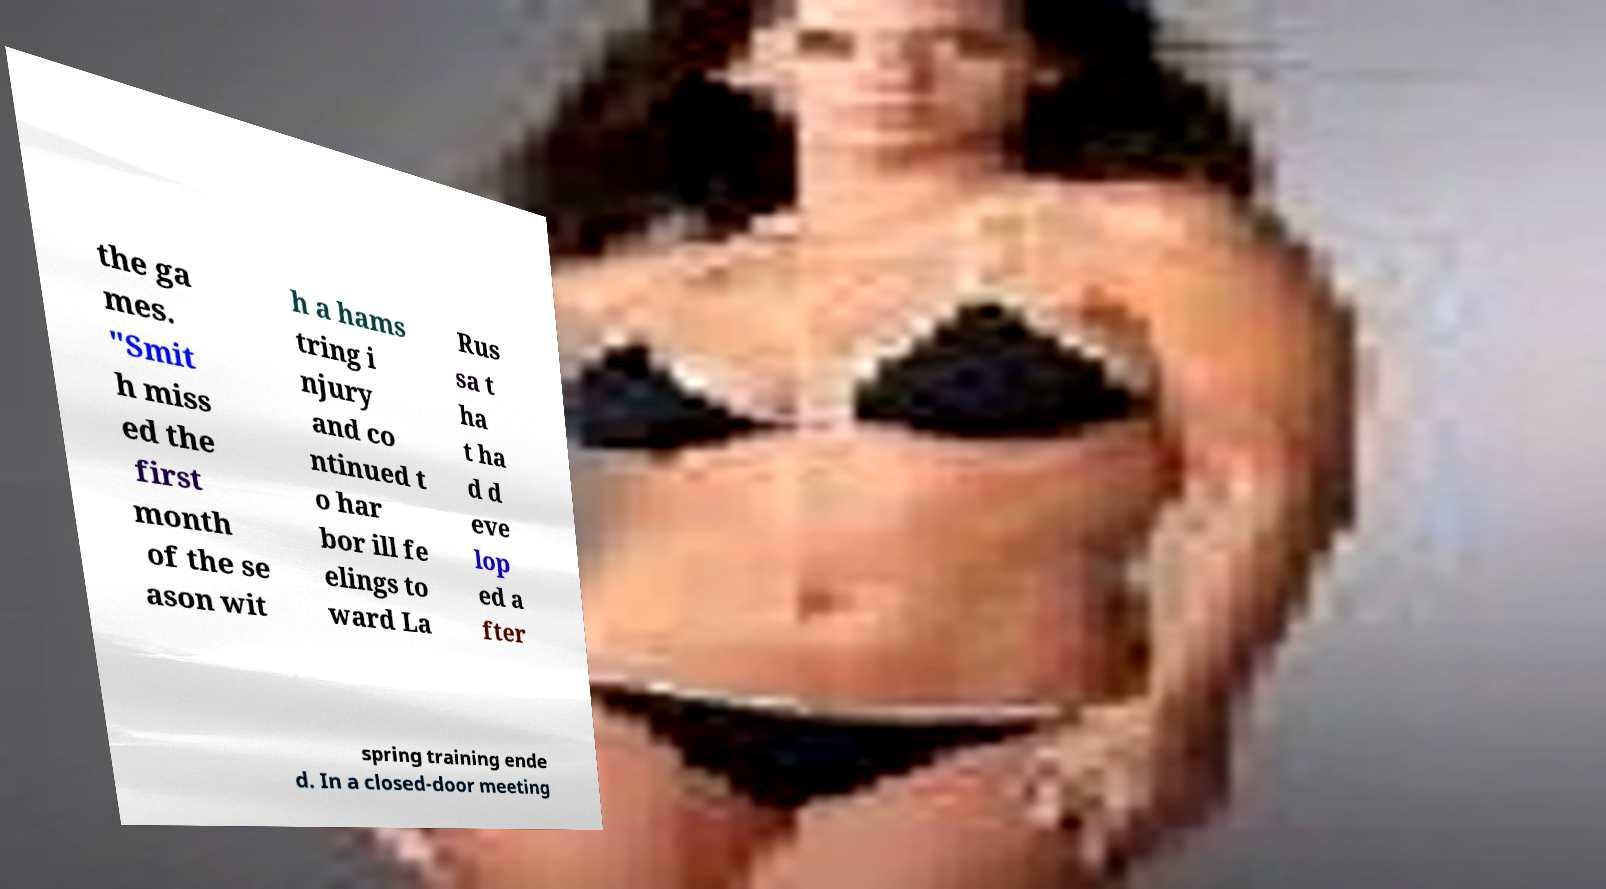I need the written content from this picture converted into text. Can you do that? the ga mes. "Smit h miss ed the first month of the se ason wit h a hams tring i njury and co ntinued t o har bor ill fe elings to ward La Rus sa t ha t ha d d eve lop ed a fter spring training ende d. In a closed-door meeting 